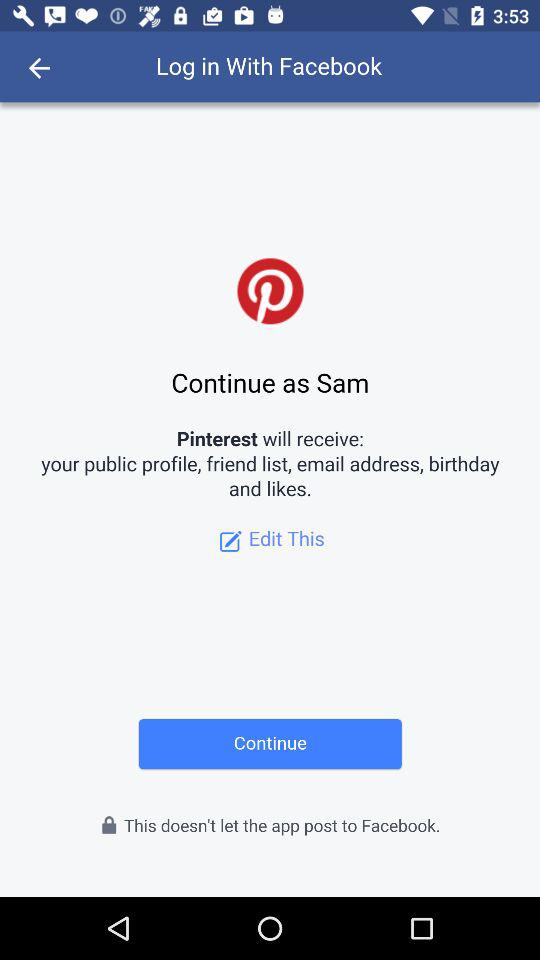Through what application is the person logging in? The person is logging in through "Facebook". 